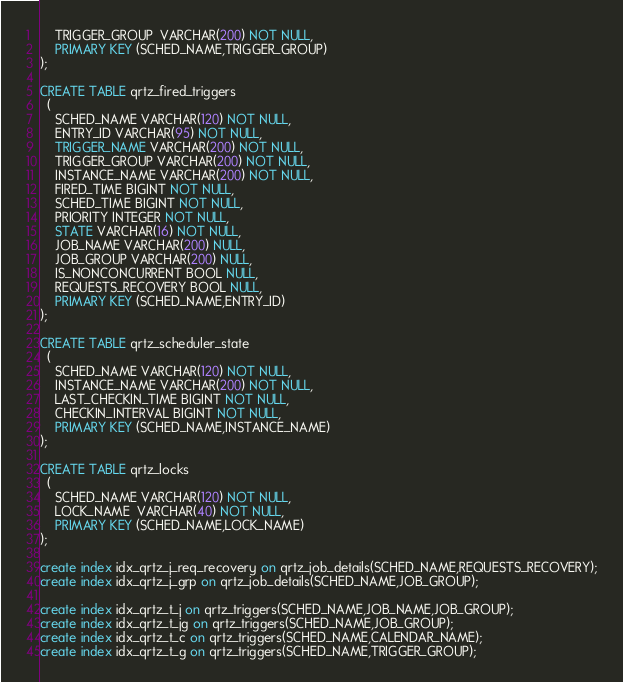Convert code to text. <code><loc_0><loc_0><loc_500><loc_500><_SQL_>    TRIGGER_GROUP  VARCHAR(200) NOT NULL, 
    PRIMARY KEY (SCHED_NAME,TRIGGER_GROUP)
);

CREATE TABLE qrtz_fired_triggers 
  (
    SCHED_NAME VARCHAR(120) NOT NULL,
    ENTRY_ID VARCHAR(95) NOT NULL,
    TRIGGER_NAME VARCHAR(200) NOT NULL,
    TRIGGER_GROUP VARCHAR(200) NOT NULL,
    INSTANCE_NAME VARCHAR(200) NOT NULL,
    FIRED_TIME BIGINT NOT NULL,
    SCHED_TIME BIGINT NOT NULL,
    PRIORITY INTEGER NOT NULL,
    STATE VARCHAR(16) NOT NULL,
    JOB_NAME VARCHAR(200) NULL,
    JOB_GROUP VARCHAR(200) NULL,
    IS_NONCONCURRENT BOOL NULL,
    REQUESTS_RECOVERY BOOL NULL,
    PRIMARY KEY (SCHED_NAME,ENTRY_ID)
);

CREATE TABLE qrtz_scheduler_state 
  (
    SCHED_NAME VARCHAR(120) NOT NULL,
    INSTANCE_NAME VARCHAR(200) NOT NULL,
    LAST_CHECKIN_TIME BIGINT NOT NULL,
    CHECKIN_INTERVAL BIGINT NOT NULL,
    PRIMARY KEY (SCHED_NAME,INSTANCE_NAME)
);

CREATE TABLE qrtz_locks
  (
    SCHED_NAME VARCHAR(120) NOT NULL,
    LOCK_NAME  VARCHAR(40) NOT NULL, 
    PRIMARY KEY (SCHED_NAME,LOCK_NAME)
);

create index idx_qrtz_j_req_recovery on qrtz_job_details(SCHED_NAME,REQUESTS_RECOVERY);
create index idx_qrtz_j_grp on qrtz_job_details(SCHED_NAME,JOB_GROUP);

create index idx_qrtz_t_j on qrtz_triggers(SCHED_NAME,JOB_NAME,JOB_GROUP);
create index idx_qrtz_t_jg on qrtz_triggers(SCHED_NAME,JOB_GROUP);
create index idx_qrtz_t_c on qrtz_triggers(SCHED_NAME,CALENDAR_NAME);
create index idx_qrtz_t_g on qrtz_triggers(SCHED_NAME,TRIGGER_GROUP);</code> 